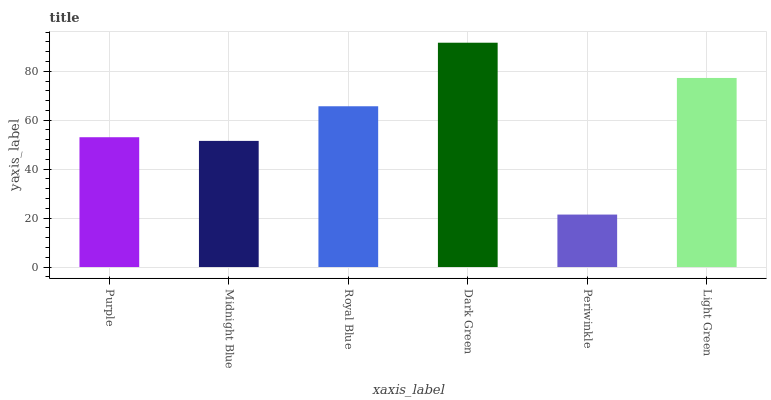Is Periwinkle the minimum?
Answer yes or no. Yes. Is Dark Green the maximum?
Answer yes or no. Yes. Is Midnight Blue the minimum?
Answer yes or no. No. Is Midnight Blue the maximum?
Answer yes or no. No. Is Purple greater than Midnight Blue?
Answer yes or no. Yes. Is Midnight Blue less than Purple?
Answer yes or no. Yes. Is Midnight Blue greater than Purple?
Answer yes or no. No. Is Purple less than Midnight Blue?
Answer yes or no. No. Is Royal Blue the high median?
Answer yes or no. Yes. Is Purple the low median?
Answer yes or no. Yes. Is Light Green the high median?
Answer yes or no. No. Is Royal Blue the low median?
Answer yes or no. No. 